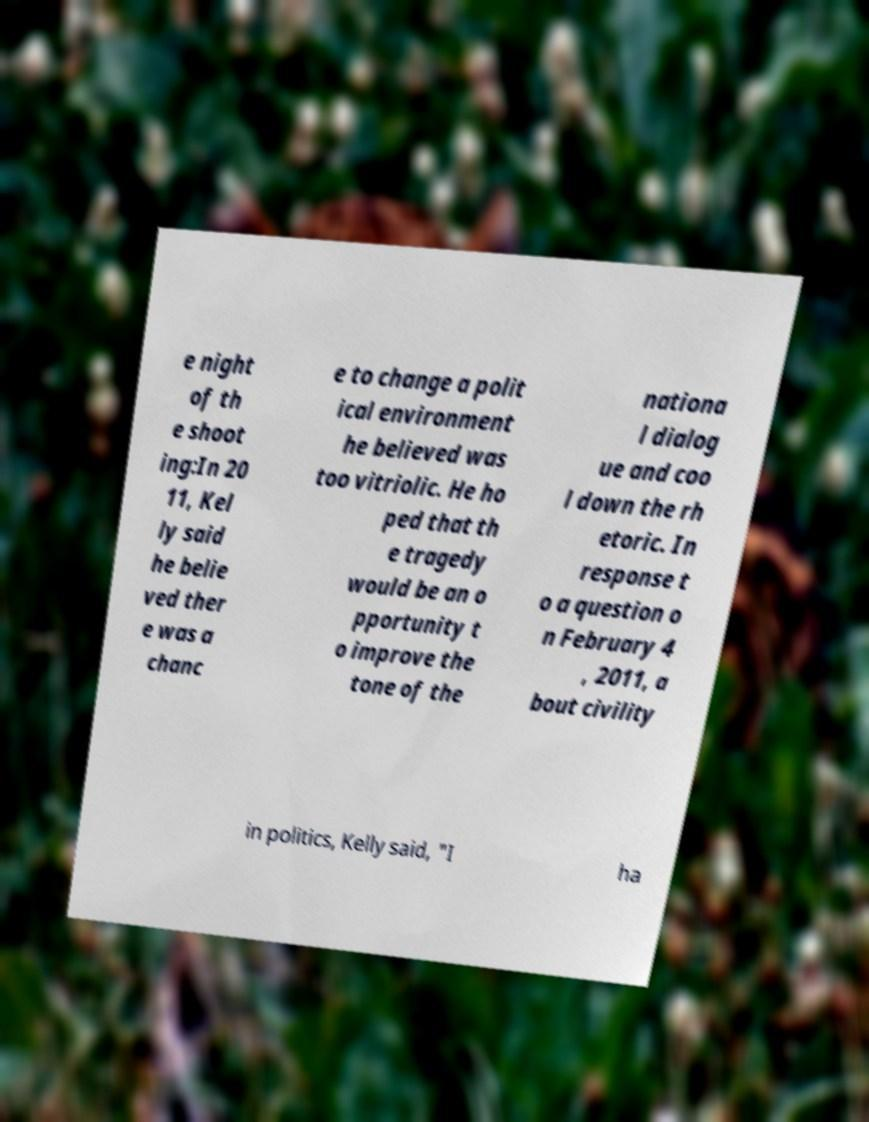Please identify and transcribe the text found in this image. e night of th e shoot ing:In 20 11, Kel ly said he belie ved ther e was a chanc e to change a polit ical environment he believed was too vitriolic. He ho ped that th e tragedy would be an o pportunity t o improve the tone of the nationa l dialog ue and coo l down the rh etoric. In response t o a question o n February 4 , 2011, a bout civility in politics, Kelly said, "I ha 